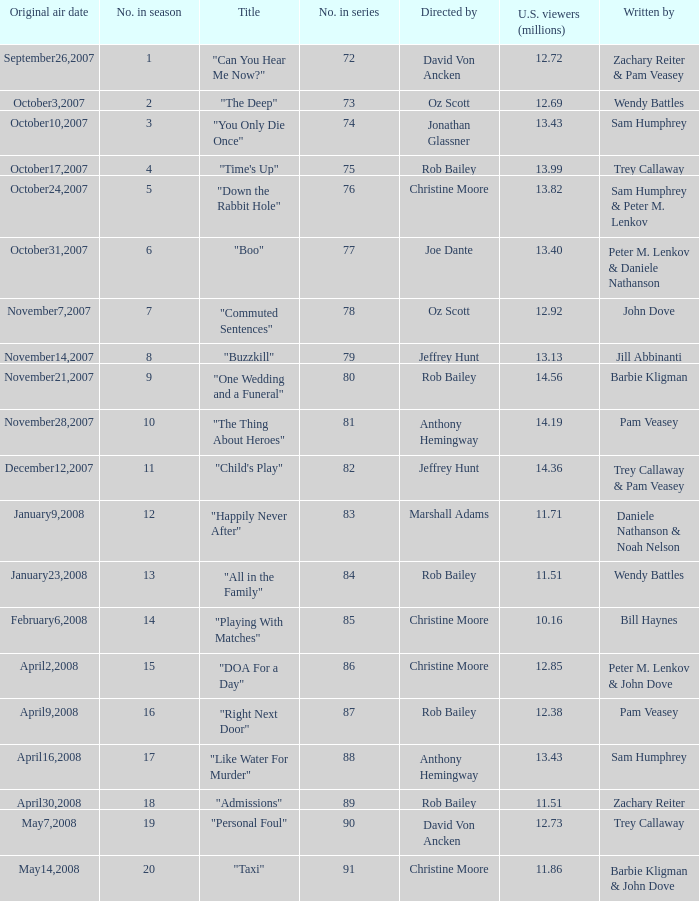How many episodes were watched by 12.72 million U.S. viewers? 1.0. 